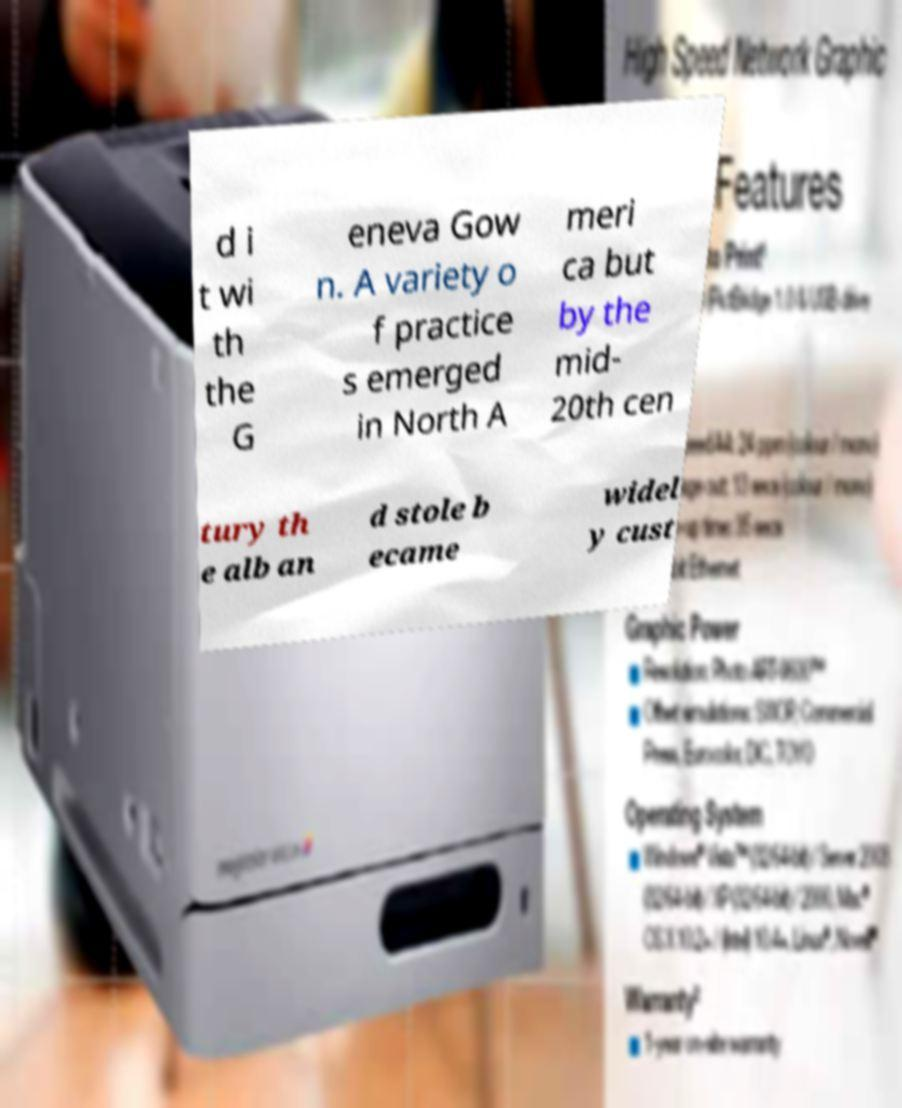Can you accurately transcribe the text from the provided image for me? d i t wi th the G eneva Gow n. A variety o f practice s emerged in North A meri ca but by the mid- 20th cen tury th e alb an d stole b ecame widel y cust 